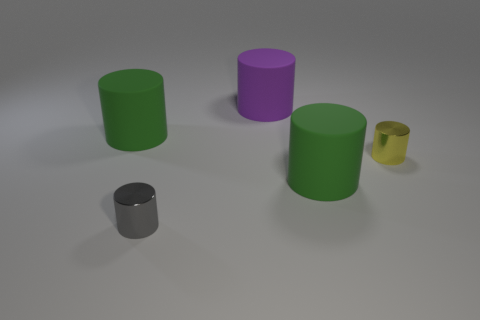Add 4 purple rubber things. How many objects exist? 9 Subtract all large gray matte blocks. Subtract all big purple objects. How many objects are left? 4 Add 2 purple cylinders. How many purple cylinders are left? 3 Add 3 small yellow shiny cylinders. How many small yellow shiny cylinders exist? 4 Subtract 0 brown balls. How many objects are left? 5 